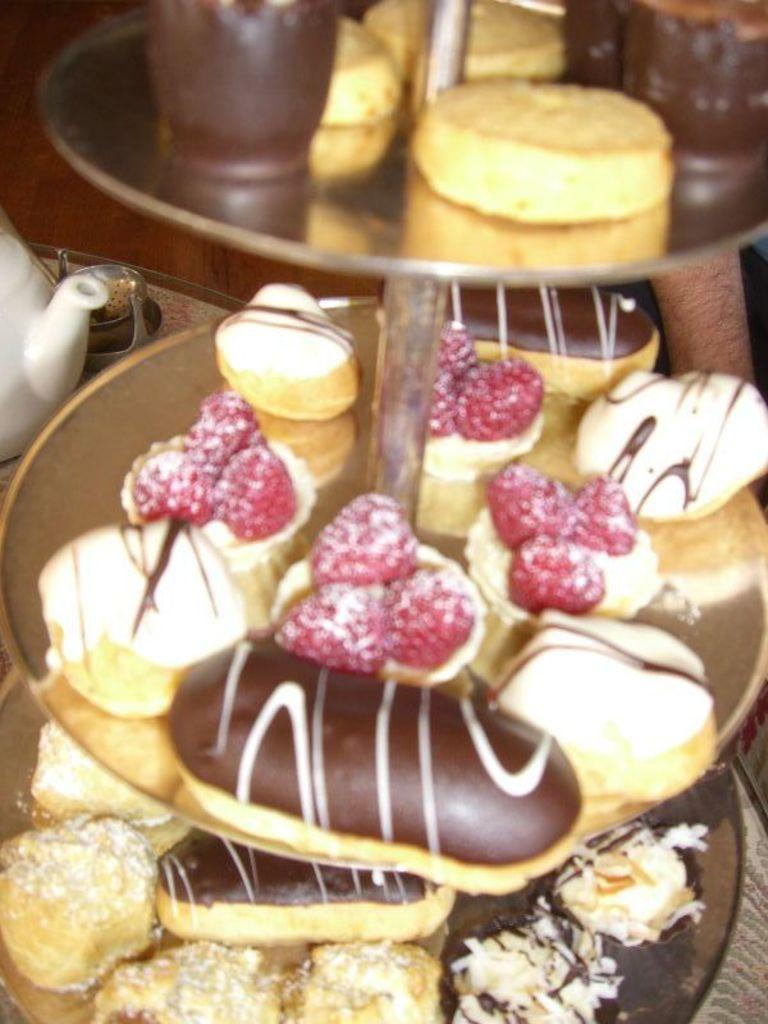What type of food items can be seen in the image? There are doughnuts, fruits, and cookies in the image. What kitchen tools are visible in the image? There are cake molds in the image. Where are the cookies placed in the image? The cookies are on a cake stand in the image. What can be seen in the background of the image? There is a kettle and other objects in the background of the image. Can you make an assumption about the location where the image might have been taken? The image may have been taken in a restaurant, given the presence of various food items and kitchen tools. What type of honey is being served with the doughnuts in the image? There is no honey present in the image; only doughnuts, fruits, and cookies are visible. What type of skirt is the person wearing in the image? There is no person wearing a skirt in the image; it is focused on food items and kitchen tools. 